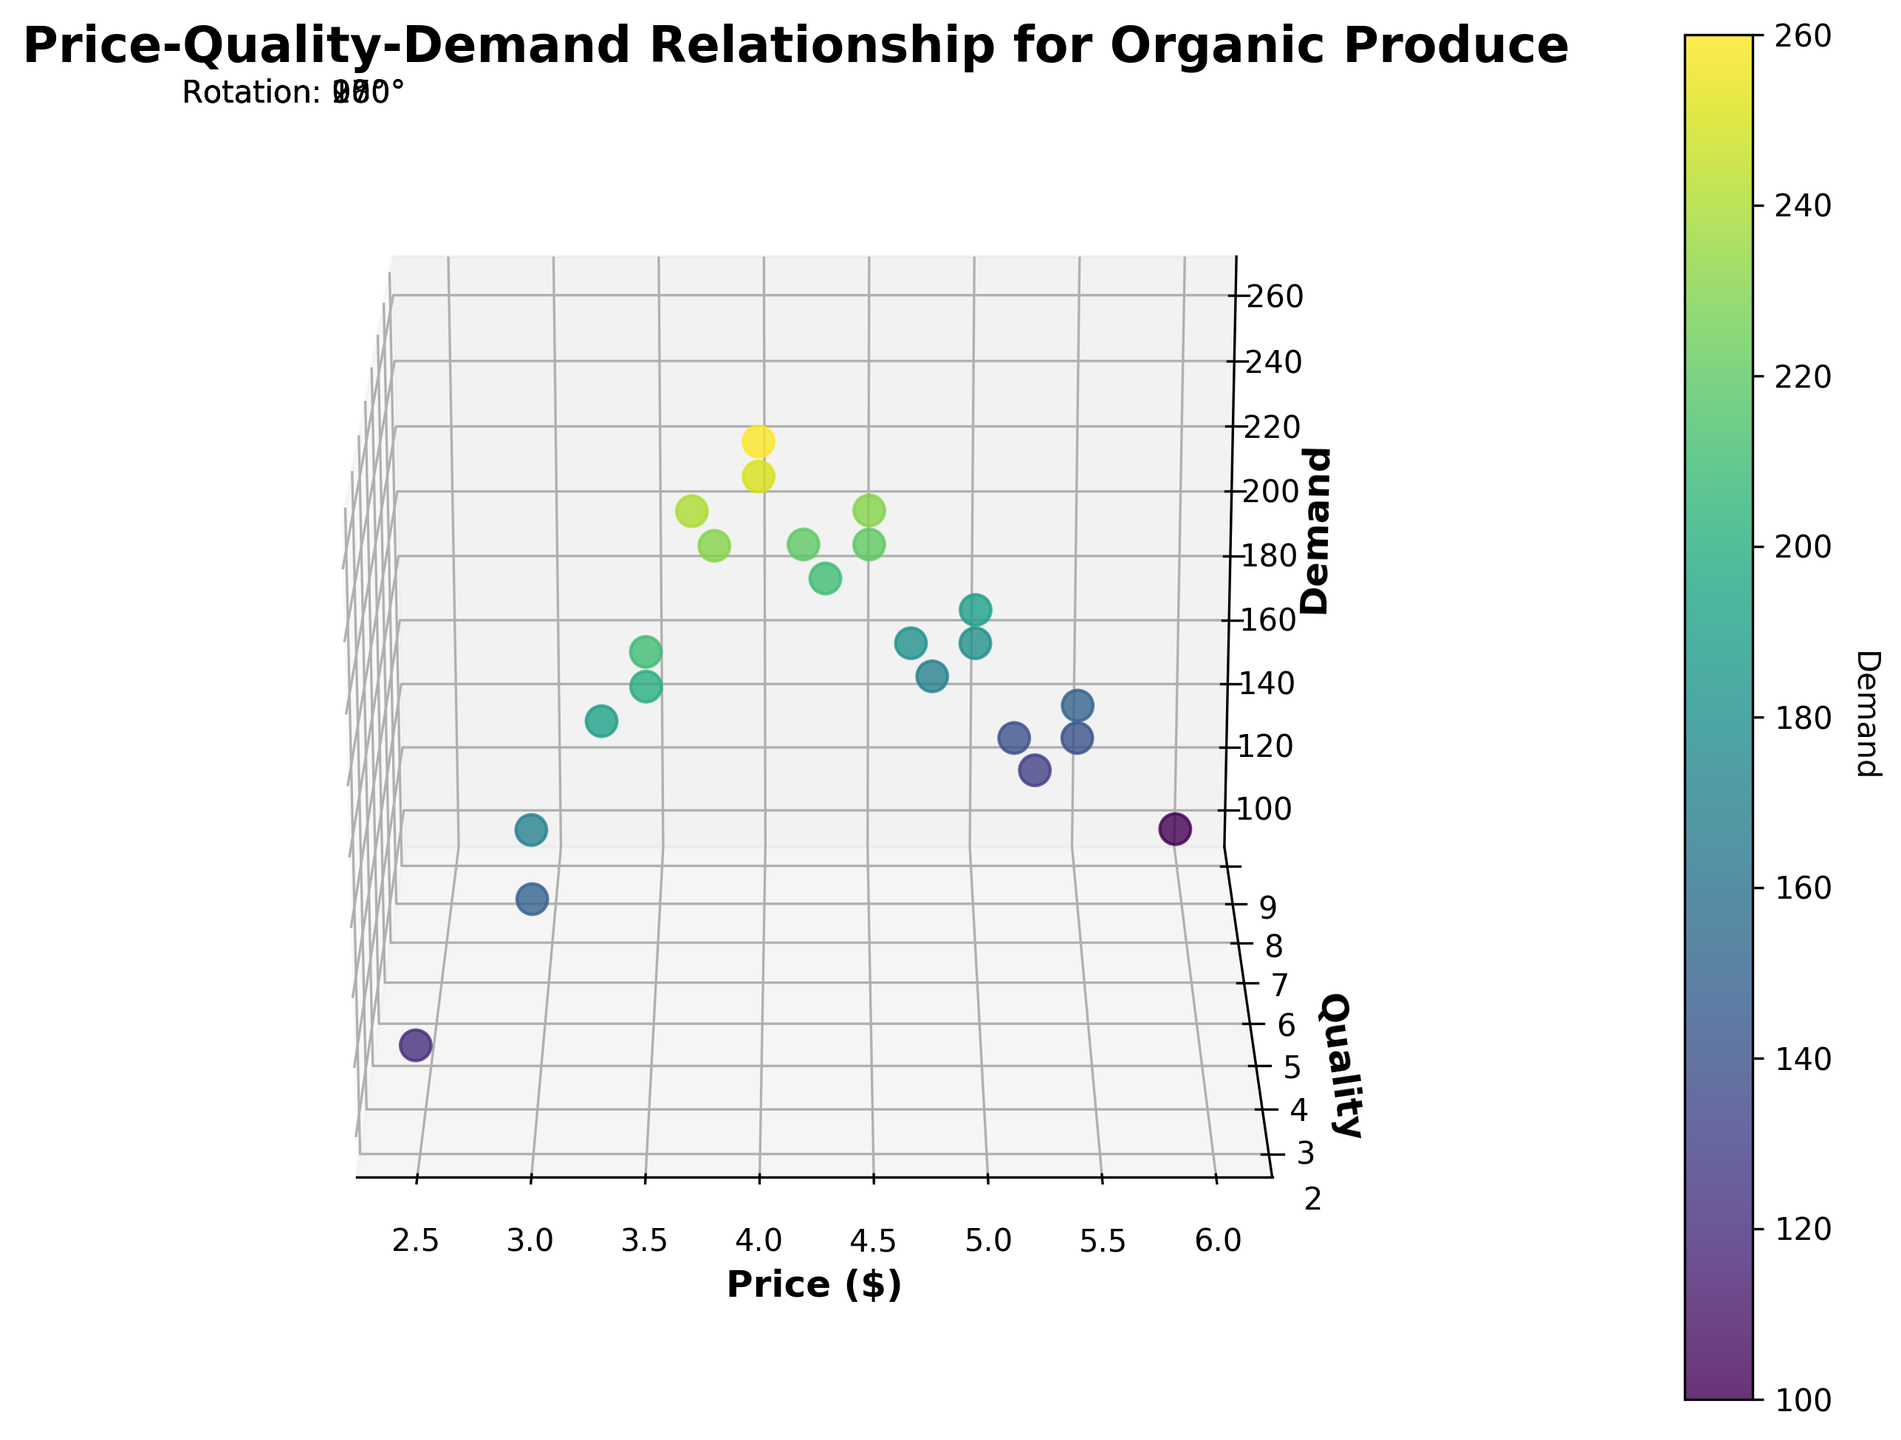What's the title of the plot? The title is usually positioned at the top of the plot and describes the content. In this case, the plot title is "Price-Quality-Demand Relationship for Organic Produce".
Answer: Price-Quality-Demand Relationship for Organic Produce What does the color intensity represent in the plot? The color intensity, according to the plot legend (color bar), represents the demand levels. Colors closer to green indicate lower demand while colors closer to yellow indicate higher demand.
Answer: Demand levels Which variable is represented on the x-axis? The label on the x-axis of the plot indicates which variable is represented. Here, the x-axis represents "Price ($)".
Answer: Price ($) What is the correlation between price and demand, based on the plot’s general observation? Based on the plot, one can observe that as the price increases, the demand generally decreases, indicated by the lower demand levels (color intensity) associated with higher price points.
Answer: Negative correlation How many data points are close to the highest demand level? By looking at the color intensity near the yellow end of the color bar, you can count the number of points. There seem to be roughly 4-5 data points showing high demand.
Answer: 4-5 data points What is the typical quality rating for produce priced around $3.99? Observing the data points around $3.99 on the x-axis, the typical quality ratings are around 5-6, as most points in this price range fall between these y-axis values.
Answer: 5-6 If the price is increased from $2.99 to $5.99, how does the demand change? To answer this, observe the data points at these price levels. At $2.99, demand is high (greenish-yellow points), while at $5.99, demand is much lower (greenish points). Therefore, demand significantly decreases as the price increases from $2.99 to $5.99.
Answer: Decreases significantly Which price point has the highest quality rating and what is the demand at that point? By locating the highest point on the quality axis and checking the corresponding price and demand levels, we find that at a price point of $5.99, the quality rating is 9, and the demand is 100.
Answer: Price=$5.99, Demand=100 Does higher quality always equate to higher demand? By examining the general pattern of points, we see that higher quality does not always equate to higher demand; in fact, some of the highest quality points have lower demand.
Answer: No Comparing prices of $4.49 and $4.99, how does the demand differ? Looking at the specific points for these prices, at $4.49 the demand is around 230-250, while at $4.99, the demand is lower, around 180-190.
Answer: Demand decreases Compare the average demand between the prices $3.49 and $5.49. To find this, calculate the average demand at $3.49 (average of 200, 210) which equals 205, and at $5.49 (average of 140, 150) which equals 145. Therefore, demand at $3.49 is higher on average.
Answer: Demand higher at $3.49 